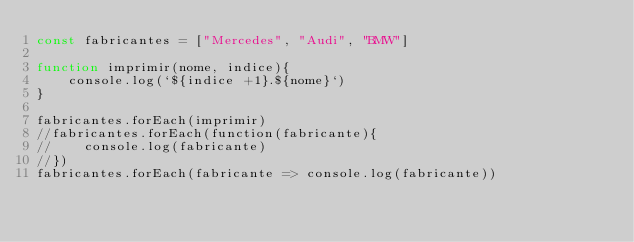<code> <loc_0><loc_0><loc_500><loc_500><_JavaScript_>const fabricantes = ["Mercedes", "Audi", "BMW"]

function imprimir(nome, indice){
    console.log(`${indice +1}.${nome}`)
}

fabricantes.forEach(imprimir)
//fabricantes.forEach(function(fabricante){
//    console.log(fabricante)
//})
fabricantes.forEach(fabricante => console.log(fabricante))</code> 